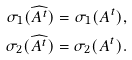Convert formula to latex. <formula><loc_0><loc_0><loc_500><loc_500>\sigma _ { 1 } ( \widehat { A ^ { t } } ) = \sigma _ { 1 } ( A ^ { t } ) , \\ \sigma _ { 2 } ( \widehat { A ^ { t } } ) = \sigma _ { 2 } ( A ^ { t } ) .</formula> 